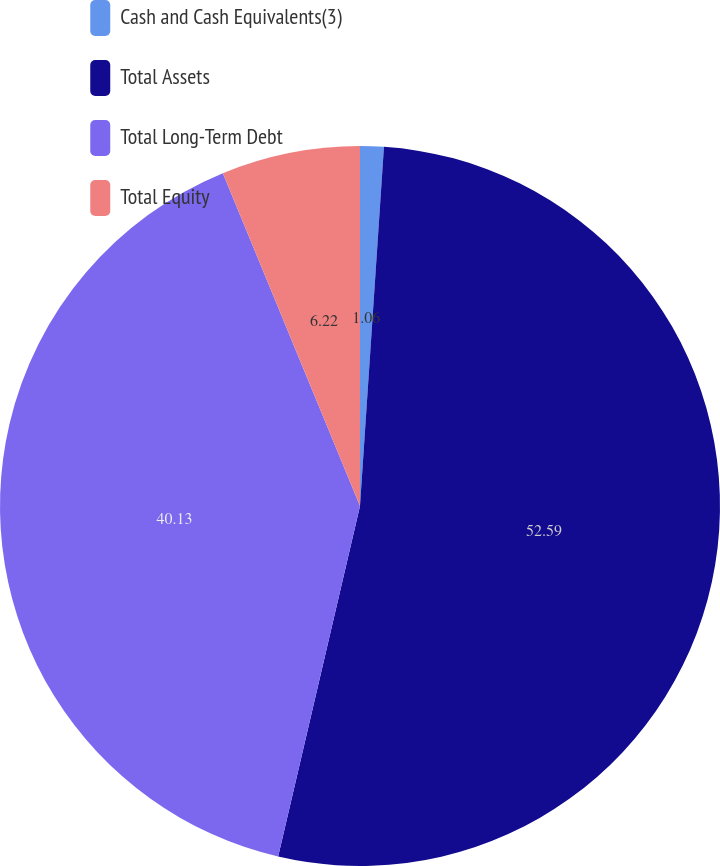Convert chart. <chart><loc_0><loc_0><loc_500><loc_500><pie_chart><fcel>Cash and Cash Equivalents(3)<fcel>Total Assets<fcel>Total Long-Term Debt<fcel>Total Equity<nl><fcel>1.06%<fcel>52.59%<fcel>40.13%<fcel>6.22%<nl></chart> 